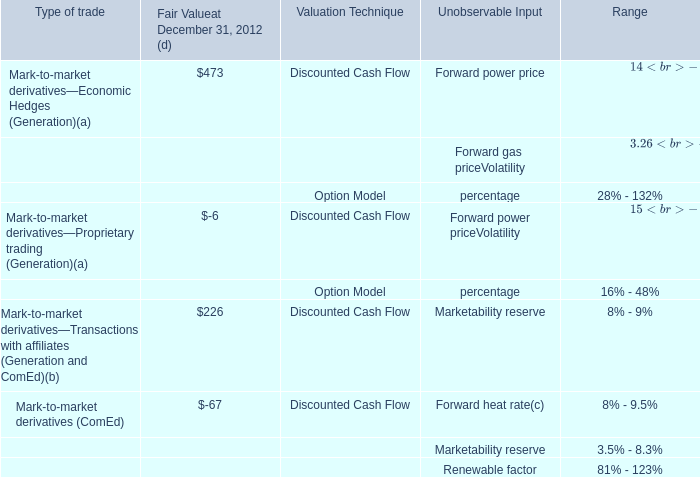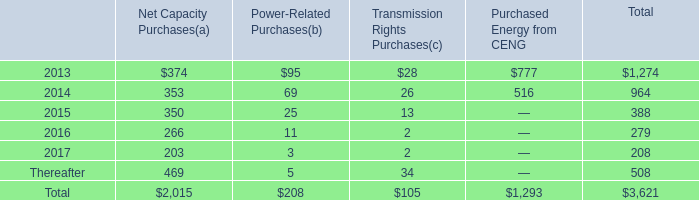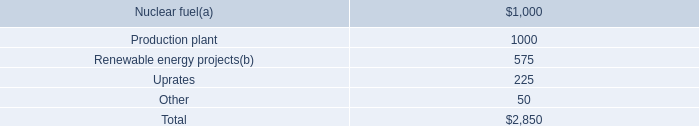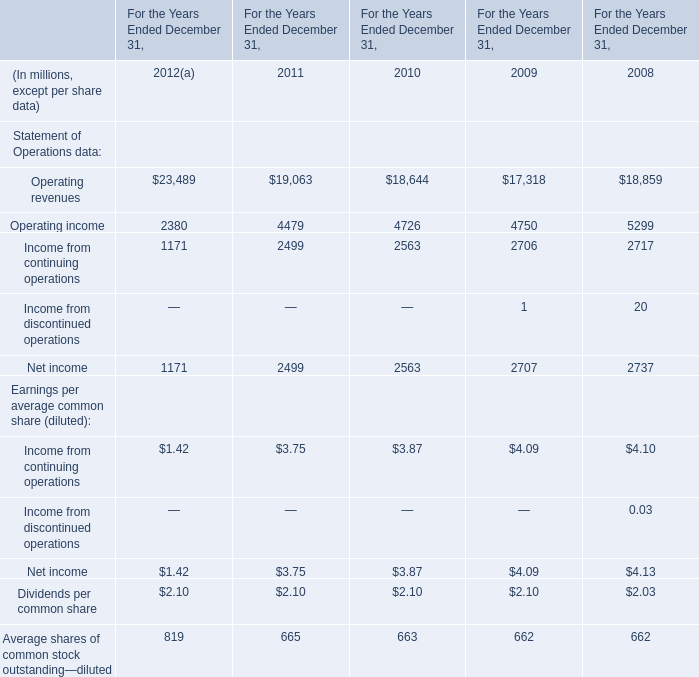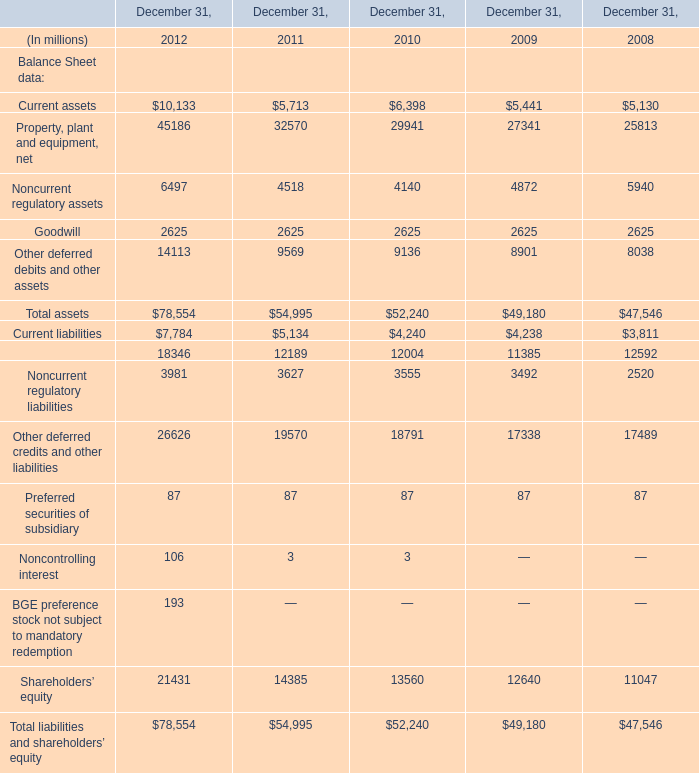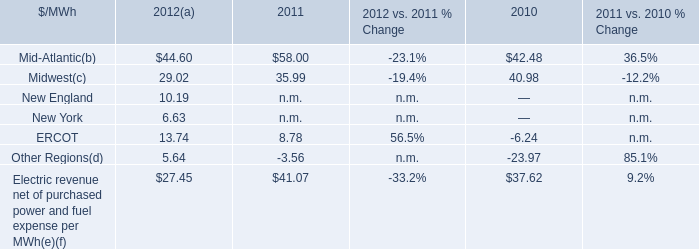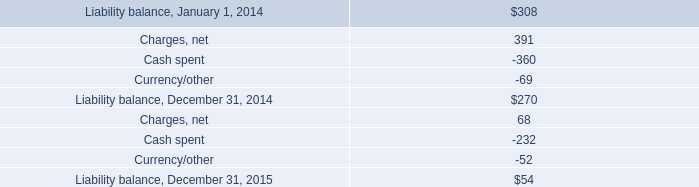What is the total amount of Property, plant and equipment, net of December 31, 2008, Operating income of For the Years Ended December 31, 2008, and Goodwill of December 31, 2012 ? 
Computations: ((25813.0 + 5299.0) + 2625.0)
Answer: 33737.0. 